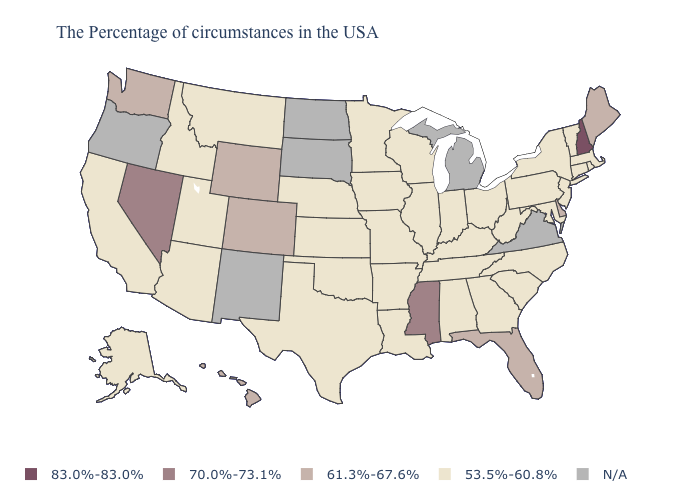What is the highest value in states that border Vermont?
Quick response, please. 83.0%-83.0%. Among the states that border Utah , which have the highest value?
Quick response, please. Nevada. Does Nevada have the highest value in the West?
Be succinct. Yes. How many symbols are there in the legend?
Short answer required. 5. What is the value of Idaho?
Quick response, please. 53.5%-60.8%. What is the lowest value in states that border Delaware?
Be succinct. 53.5%-60.8%. Name the states that have a value in the range 83.0%-83.0%?
Answer briefly. New Hampshire. Among the states that border Iowa , which have the highest value?
Answer briefly. Wisconsin, Illinois, Missouri, Minnesota, Nebraska. Which states have the lowest value in the MidWest?
Quick response, please. Ohio, Indiana, Wisconsin, Illinois, Missouri, Minnesota, Iowa, Kansas, Nebraska. How many symbols are there in the legend?
Write a very short answer. 5. Which states have the lowest value in the USA?
Write a very short answer. Massachusetts, Rhode Island, Vermont, Connecticut, New York, New Jersey, Maryland, Pennsylvania, North Carolina, South Carolina, West Virginia, Ohio, Georgia, Kentucky, Indiana, Alabama, Tennessee, Wisconsin, Illinois, Louisiana, Missouri, Arkansas, Minnesota, Iowa, Kansas, Nebraska, Oklahoma, Texas, Utah, Montana, Arizona, Idaho, California, Alaska. 